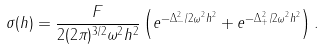Convert formula to latex. <formula><loc_0><loc_0><loc_500><loc_500>\sigma ( h ) = \frac { F } { 2 ( 2 \pi ) ^ { 3 / 2 } \omega ^ { 2 } h ^ { 2 } } \left ( e ^ { - \Delta _ { - } ^ { 2 } / 2 \omega ^ { 2 } h ^ { 2 } } + e ^ { - \Delta _ { + } ^ { 2 } / 2 \omega ^ { 2 } h ^ { 2 } } \right ) .</formula> 